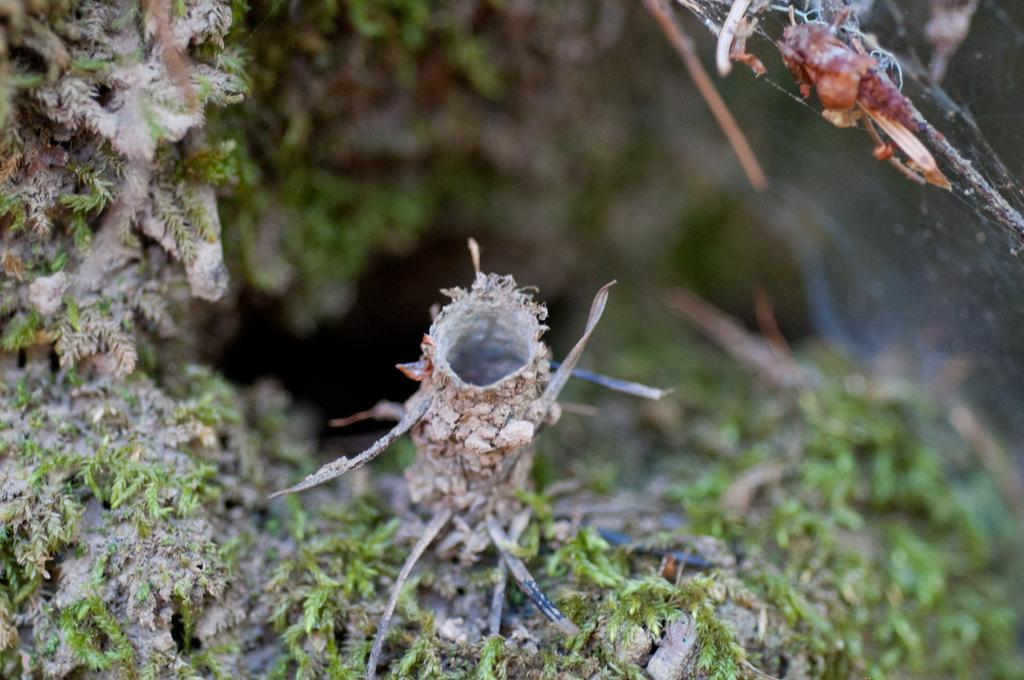What type of vegetation can be seen on the ground in the image? There are small plants on the ground in the image. What feature is present in the ground in the image? There is a hole in the ground in the image. What can be seen on the right side of the image? There is a spider web on the right side of the image. What hobbies do the cats in the image have? There are no cats present in the image. How does the spider web need to be adjusted in the image? The spider web does not need to be adjusted in the image; it is already present as a static feature. 